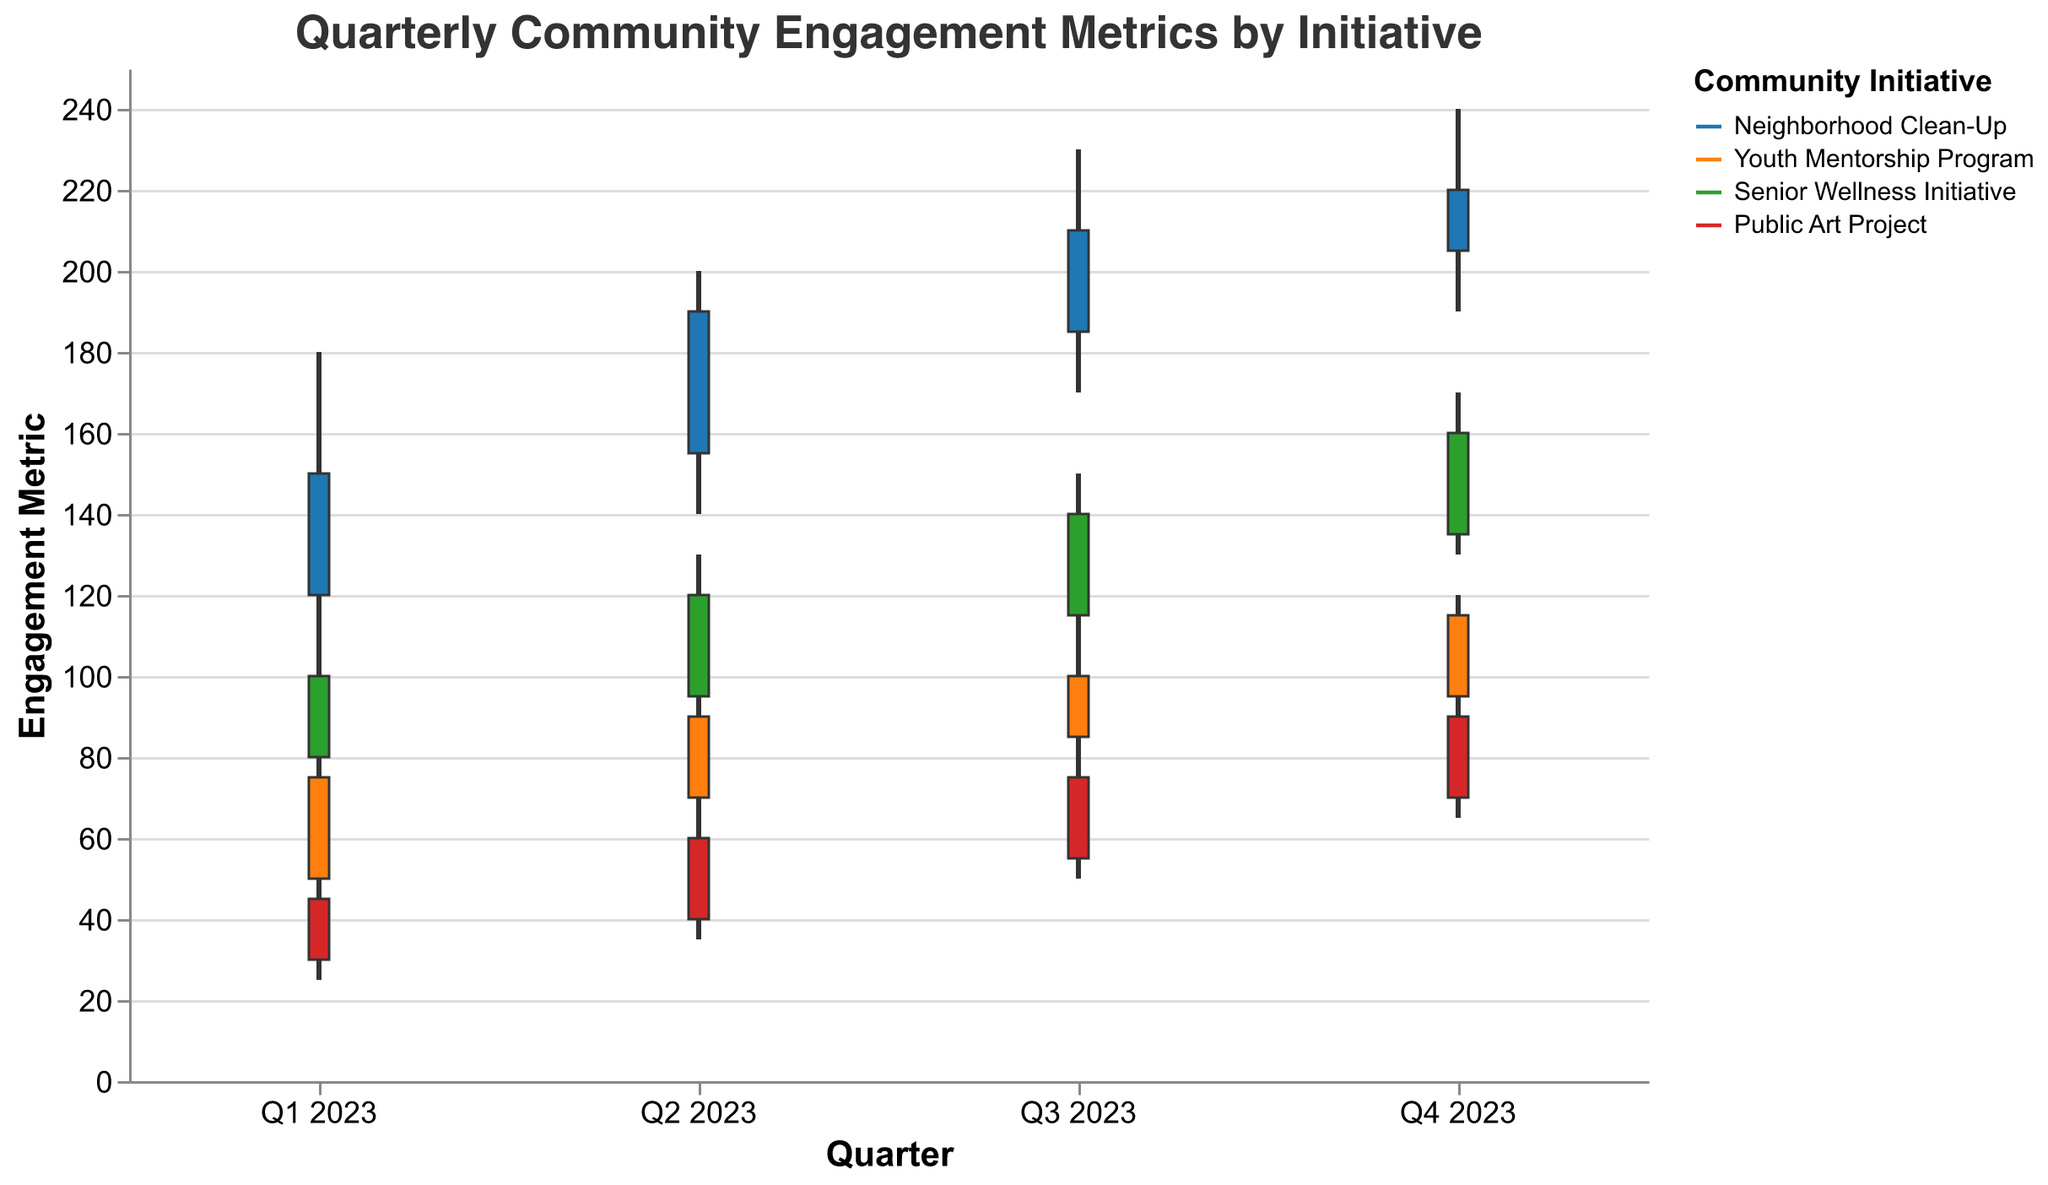What is the title of the figure? The title is displayed at the top of the figure in a larger font. It reads "Quarterly Community Engagement Metrics by Initiative."
Answer: Quarterly Community Engagement Metrics by Initiative Which initiative had the highest engagement metric in Q4 2023, and what was that value? The highest engagement metric is indicated by the highest "High" value in Q4 2023. For the "Neighborhood Clean-Up" initiative, the high value is 240, which is the highest among all initiatives.
Answer: Neighborhood Clean-Up, 240 How did the engagement metric for the Youth Mentorship Program change from Q1 2023 to Q2 2023? To determine the change, we compare the "Close" value in Q1 2023, which is 75, to the "Close" value in Q2 2023, which is 90. The change is calculated as 90 - 75.
Answer: Increased by 15 What was the range of engagement metrics for the Senior Wellness Initiative in Q3 2023? The range is determined by the difference between the "High" value and the "Low" value in Q3 2023. For the "Senior Wellness Initiative," the high value is 150 and the low value is 110. The range is 150 - 110.
Answer: 40 Among all initiatives, which quarter and initiative showed the smallest range in engagement metrics, and what is that range? The range is calculated as the difference between the "High" and "Low" values for each quarter and initiative. The smallest range is found for the "Youth Mentorship Program" in Q4 2023 with a high of 120 and a low of 90. The range is 120 - 90.
Answer: Q4 2023, Youth Mentorship Program, 30 What was the general trend for the Public Art Project throughout 2023? Observing the "Close" values for each quarter of 2023, we see a general increase from Q1 (45), Q2 (60), Q3 (75), to Q4 (90). This indicates a consistent upward trend in engagement.
Answer: Upward trend Comparing Q1 2023 to Q4 2023, which initiative had the most significant increase in closing engagement metrics? We calculate the difference between the "Close" values for Q1 and Q4 for each initiative. The largest difference is seen in the "Public Art Project," increasing from 45 in Q1 to 90 in Q4. The increase is 90 - 45.
Answer: Public Art Project, 45 What are the open and close values for the Neighborhood Clean-Up initiative in Q3 2023? The "Open" value is found in the corresponding data for Q3 2023, which is 185. The "Close" value for the same period is 210.
Answer: Open: 185, Close: 210 